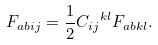Convert formula to latex. <formula><loc_0><loc_0><loc_500><loc_500>F _ { a b i j } = \frac { 1 } { 2 } { C _ { i j } } ^ { k l } { F _ { a b k l } } .</formula> 